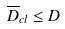<formula> <loc_0><loc_0><loc_500><loc_500>\overline { D } _ { c l } \leq D</formula> 